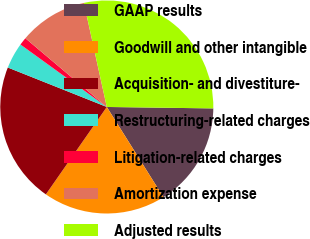Convert chart to OTSL. <chart><loc_0><loc_0><loc_500><loc_500><pie_chart><fcel>GAAP results<fcel>Goodwill and other intangible<fcel>Acquisition- and divestiture-<fcel>Restructuring-related charges<fcel>Litigation-related charges<fcel>Amortization expense<fcel>Adjusted results<nl><fcel>15.86%<fcel>18.61%<fcel>21.35%<fcel>3.93%<fcel>1.19%<fcel>10.4%<fcel>28.66%<nl></chart> 